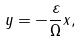<formula> <loc_0><loc_0><loc_500><loc_500>y = - \frac { \varepsilon } { \Omega } x ,</formula> 